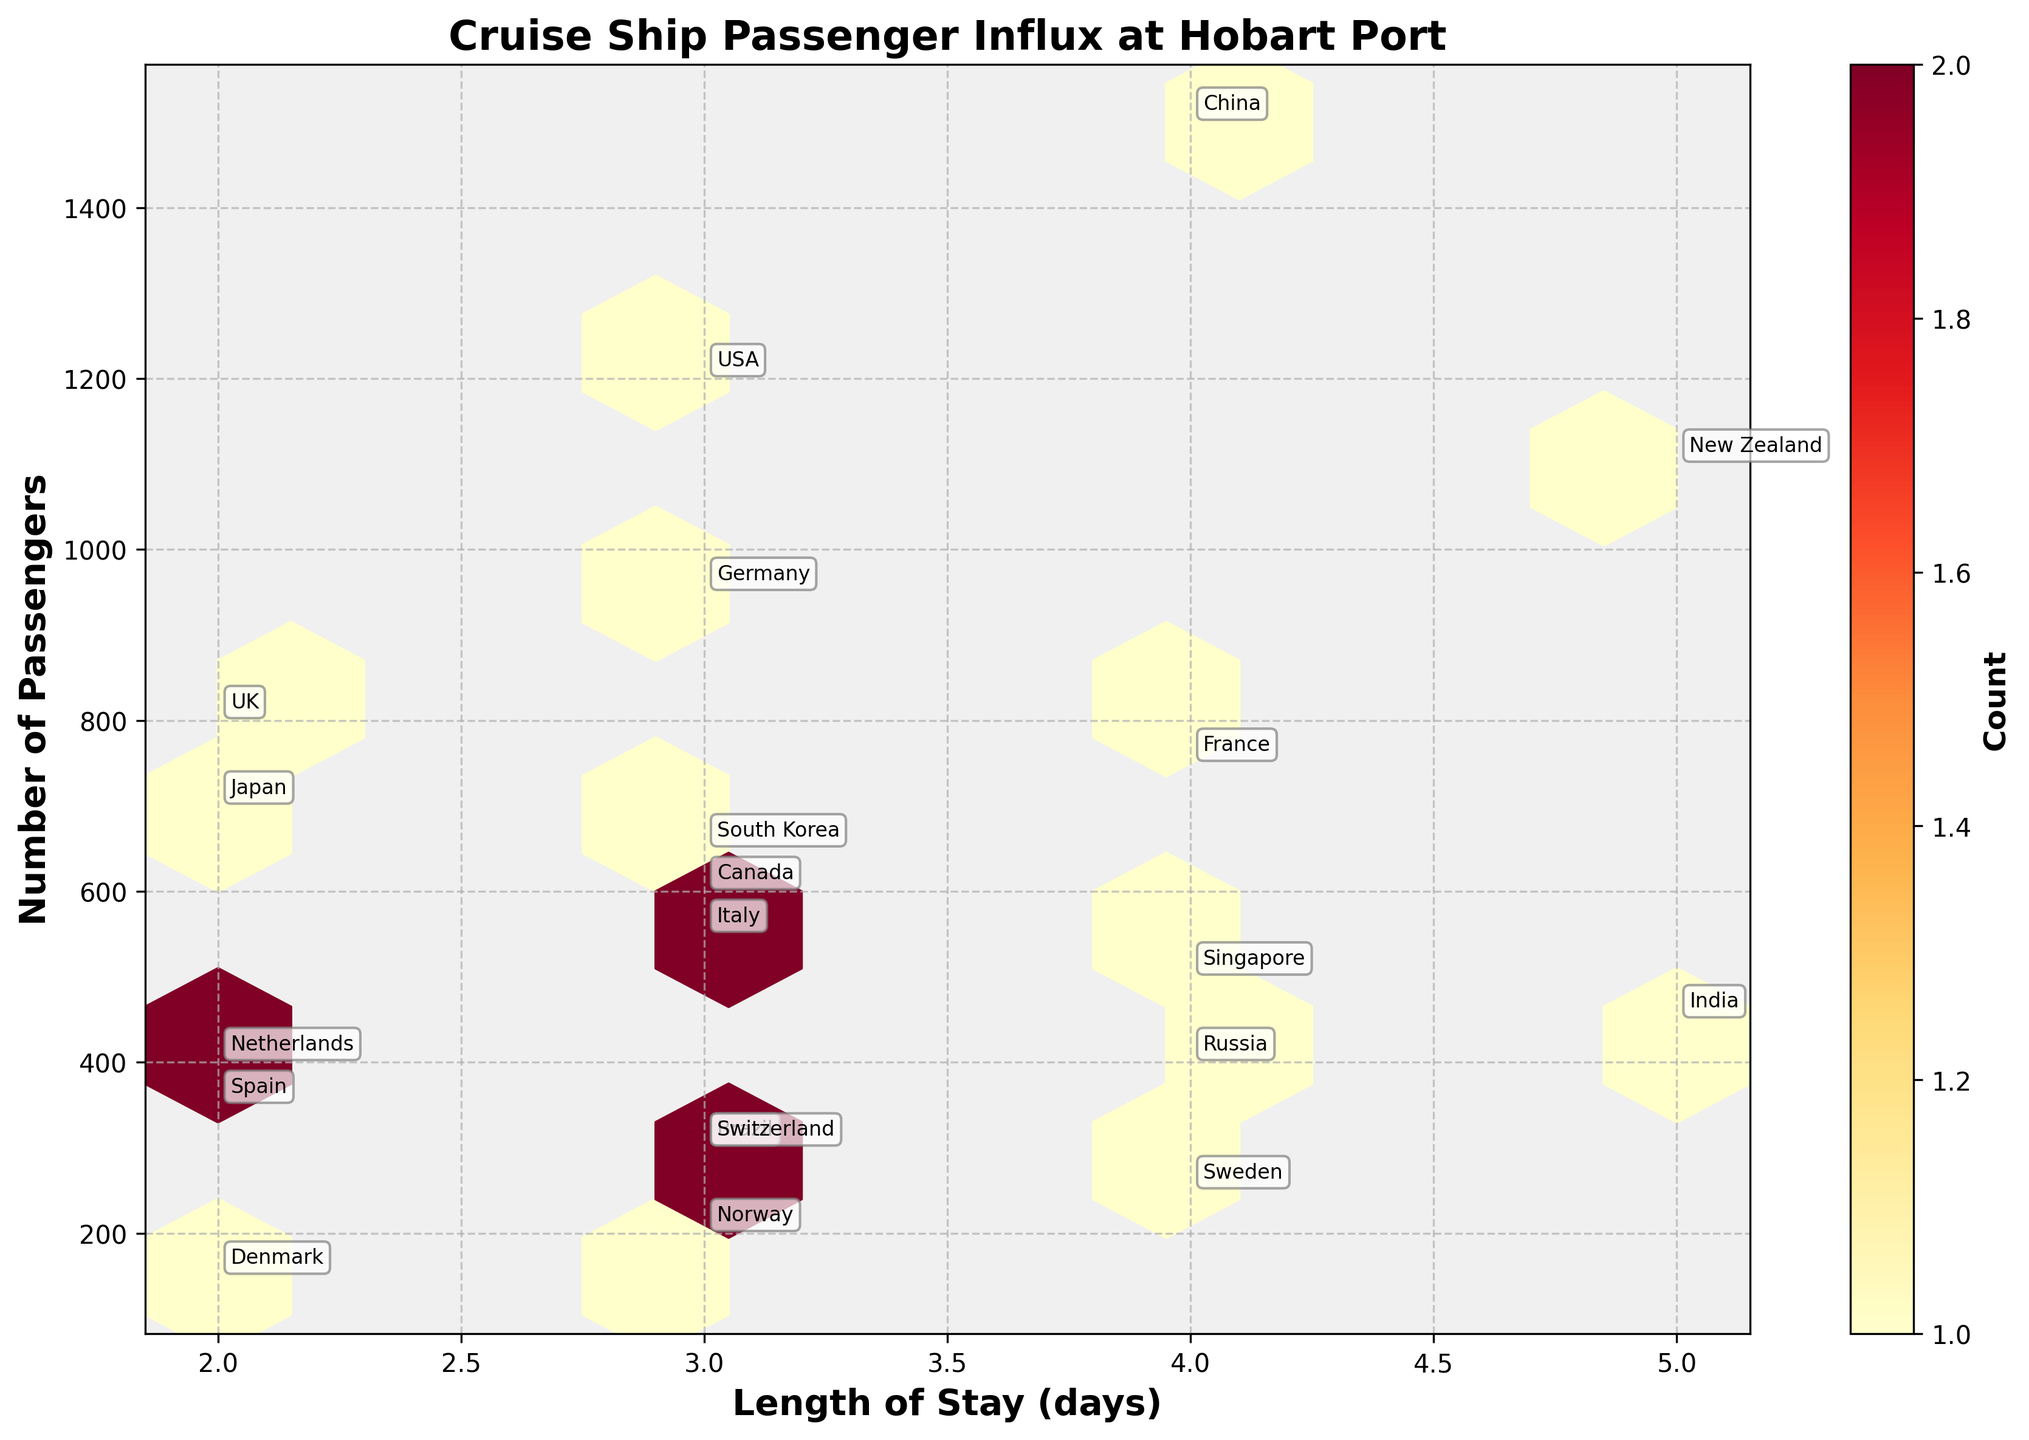what is the title of the plot? The title of the plot is displayed at the top center of the figure, indicating the subject of the visualization.
Answer: Cruise Ship Passenger Influx at Hobart Port What is the label of the X-axis? The label of the X-axis can be found directly below the X-axis, describing what the axis represents.
Answer: Length of Stay (days) What is the label of the Y-axis? The label of the Y-axis can be found directly beside the Y-axis on its left, describing what the axis represents.
Answer: Number of Passengers What is the color of the hexagons representing the highest count of data points? The color representing the highest count can be inferred from the color gradient of the hexagons provided in the legend. The hexagons with the highest count are represented by the darkest color.
Answer: Dark red How many countries have a length of stay of 4 days? To find this information, we look for the hexagons that lie along the '4 days' mark on the X-axis and count the corresponding annotated labels.
Answer: 5 Which country has the highest number of cruise ship passengers staying for 3 days? Look at the hexagon positioned at the '3 days' mark along the X-axis and identify the country with the highest Y-axis value within that hexagon.
Answer: USA What is the total number of passengers from countries where the length of stay is 2 days? First, identify the countries with a length of stay of 2 days (UK, Japan, Netherlands, Spain, Denmark), then sum their passenger counts: 800 + 700 + 400 + 350 + 150.
Answer: 2,400 Which country has the shortest length of stay and how many passengers are there from that country? Observing from annotations, identify the country with the shortest length on the X-axis and its corresponding passenger count on the Y-axis.
Answer: Denmark, 150 Compare the number of passengers from New Zealand and Japan; which country has more and by how much? Locate the corresponding hexagons for New Zealand and Japan, compare their Y-axis values, and calculate the difference (New Zealand: 1100, Japan: 700).
Answer: New Zealand by 400 Which countries have passengers between 200 to 300 for a stay length of 3 days? Identify the hexagons along the '3 days' mark on the X-axis that fall between the 200 to 300 interval and note the annotated countries.
Answer: Brazil, Switzerland, Norway 